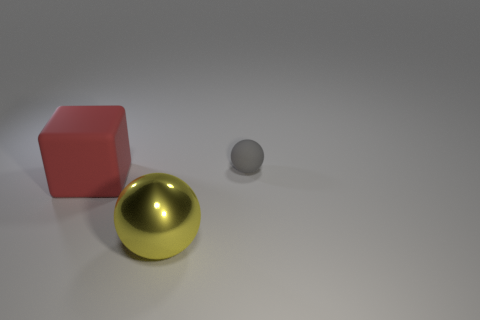Are there any other things that have the same size as the gray matte sphere?
Provide a succinct answer. No. Are there any other things that are the same shape as the red rubber object?
Your answer should be very brief. No. The yellow object is what size?
Offer a very short reply. Large. Does the thing that is on the left side of the big yellow object have the same size as the ball to the right of the large yellow metallic thing?
Ensure brevity in your answer.  No. What is the size of the gray object that is the same shape as the yellow object?
Your response must be concise. Small. Does the yellow shiny object have the same size as the ball behind the large red object?
Offer a very short reply. No. There is a thing behind the red rubber block; is there a large yellow sphere that is in front of it?
Give a very brief answer. Yes. There is a object that is left of the yellow thing; what is its shape?
Your answer should be compact. Cube. What is the color of the rubber thing that is left of the ball that is in front of the big matte object?
Provide a short and direct response. Red. Do the yellow metallic sphere and the gray thing have the same size?
Your answer should be very brief. No. 